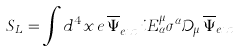<formula> <loc_0><loc_0><loc_500><loc_500>S _ { L } = \int d ^ { 4 } x \, e \, \overline { \Psi } _ { e x t } ^ { \dagger } \, i E _ { \alpha } ^ { \mu } \sigma ^ { \alpha } \mathcal { D } _ { \mu } \, \overline { \Psi } _ { e x t }</formula> 